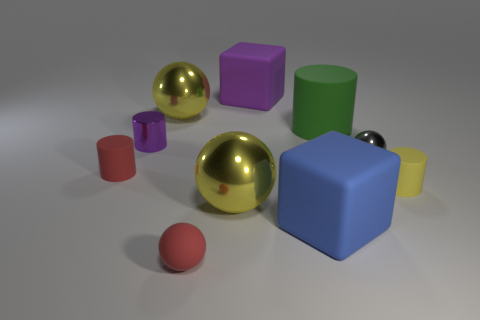What is the tiny red thing that is behind the blue block made of?
Your answer should be compact. Rubber. Are there the same number of red things that are behind the red rubber cylinder and yellow cylinders?
Keep it short and to the point. No. Do the green rubber thing and the gray thing have the same size?
Offer a very short reply. No. Is there a gray object that is behind the ball to the right of the block that is behind the large green object?
Provide a short and direct response. No. What is the material of the small purple object that is the same shape as the green object?
Your answer should be compact. Metal. There is a large metallic object that is behind the green cylinder; what number of tiny metallic cylinders are right of it?
Ensure brevity in your answer.  0. There is a yellow shiny sphere behind the tiny sphere right of the matte block in front of the big purple matte thing; how big is it?
Ensure brevity in your answer.  Large. What is the color of the block that is behind the yellow object right of the small gray thing?
Provide a short and direct response. Purple. How many other objects are there of the same material as the green thing?
Offer a terse response. 5. What number of other things are there of the same color as the metallic cylinder?
Provide a succinct answer. 1. 